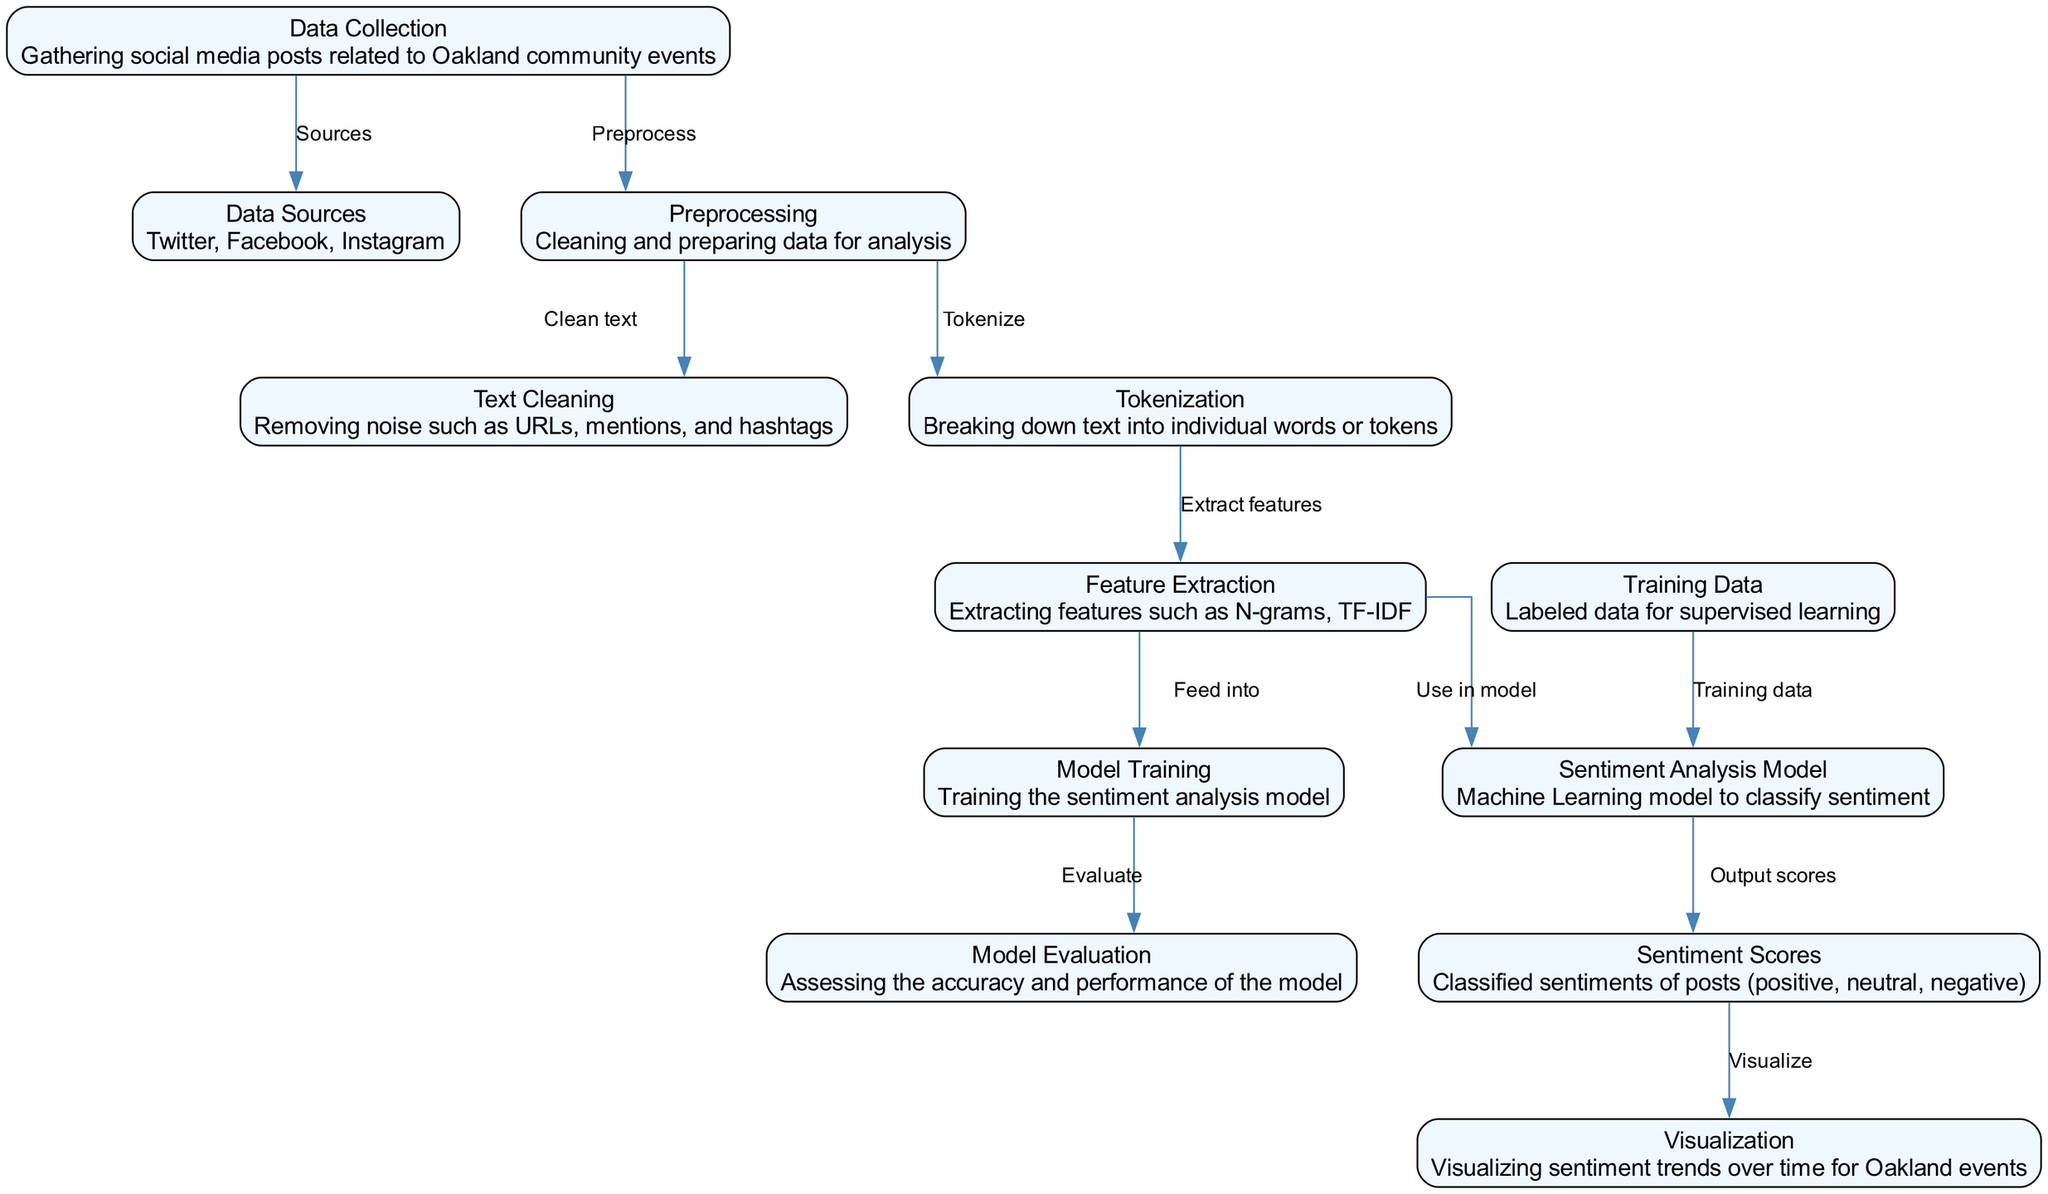What is the first step in the diagram? The diagram indicates that "Data Collection" is the first node, which involves gathering social media posts related to Oakland community events.
Answer: Data Collection How many nodes are in the diagram? There are a total of 12 nodes, each representing a distinct step in the sentiment analysis process.
Answer: 12 What nodes are directly connected to the "Preprocessing" node? The "Preprocessing" node is directly connected to "Text Cleaning" and "Tokenization", indicating they are both processes that follow it.
Answer: Text Cleaning, Tokenization What type of data is the "Training Data" node associated with? The "Training Data" node refers to labeled data used in supervised learning, which is necessary for training the sentiment analysis model.
Answer: Labeled data Which node outputs sentiment scores? The "Sentiment Analysis Model" node produces the output scores that classify the sentiment of the social media posts, resulting in positive, neutral, or negative classifications.
Answer: Sentiment Analysis Model What is the relationship between "Feature Extraction" and "Model Training"? "Feature Extraction" provides the necessary features extracted from the tokenized text that are used as input for "Model Training" to build the model.
Answer: Feed into Which node is responsible for visualizing sentiment trends over time? The "Visualization" node is dedicated to displaying sentiment trends based on the classified sentiments outputted by the model.
Answer: Visualization How is the "Sentiment Analysis Model" trained? The "Sentiment Analysis Model" is trained using the "Training Data" node, which consists of labeled examples from the collected social media posts.
Answer: Training Data What precedes the "Model Evaluation" step in the diagram? The "Model Training" step comes before "Model Evaluation", where the trained model's performance and accuracy are assessed.
Answer: Model Training What node follows the "Sentiment Scores" node in the flow of the diagram? The "Visualization" node follows the "Sentiment Scores" node, indicating that the classified sentiments are visualized after generation.
Answer: Visualization 